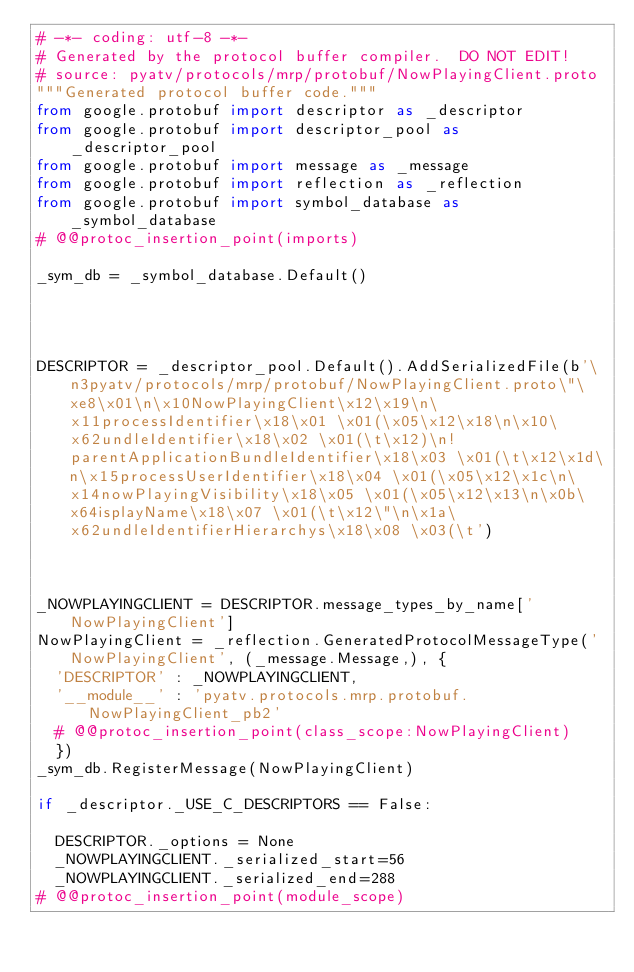Convert code to text. <code><loc_0><loc_0><loc_500><loc_500><_Python_># -*- coding: utf-8 -*-
# Generated by the protocol buffer compiler.  DO NOT EDIT!
# source: pyatv/protocols/mrp/protobuf/NowPlayingClient.proto
"""Generated protocol buffer code."""
from google.protobuf import descriptor as _descriptor
from google.protobuf import descriptor_pool as _descriptor_pool
from google.protobuf import message as _message
from google.protobuf import reflection as _reflection
from google.protobuf import symbol_database as _symbol_database
# @@protoc_insertion_point(imports)

_sym_db = _symbol_database.Default()




DESCRIPTOR = _descriptor_pool.Default().AddSerializedFile(b'\n3pyatv/protocols/mrp/protobuf/NowPlayingClient.proto\"\xe8\x01\n\x10NowPlayingClient\x12\x19\n\x11processIdentifier\x18\x01 \x01(\x05\x12\x18\n\x10\x62undleIdentifier\x18\x02 \x01(\t\x12)\n!parentApplicationBundleIdentifier\x18\x03 \x01(\t\x12\x1d\n\x15processUserIdentifier\x18\x04 \x01(\x05\x12\x1c\n\x14nowPlayingVisibility\x18\x05 \x01(\x05\x12\x13\n\x0b\x64isplayName\x18\x07 \x01(\t\x12\"\n\x1a\x62undleIdentifierHierarchys\x18\x08 \x03(\t')



_NOWPLAYINGCLIENT = DESCRIPTOR.message_types_by_name['NowPlayingClient']
NowPlayingClient = _reflection.GeneratedProtocolMessageType('NowPlayingClient', (_message.Message,), {
  'DESCRIPTOR' : _NOWPLAYINGCLIENT,
  '__module__' : 'pyatv.protocols.mrp.protobuf.NowPlayingClient_pb2'
  # @@protoc_insertion_point(class_scope:NowPlayingClient)
  })
_sym_db.RegisterMessage(NowPlayingClient)

if _descriptor._USE_C_DESCRIPTORS == False:

  DESCRIPTOR._options = None
  _NOWPLAYINGCLIENT._serialized_start=56
  _NOWPLAYINGCLIENT._serialized_end=288
# @@protoc_insertion_point(module_scope)
</code> 